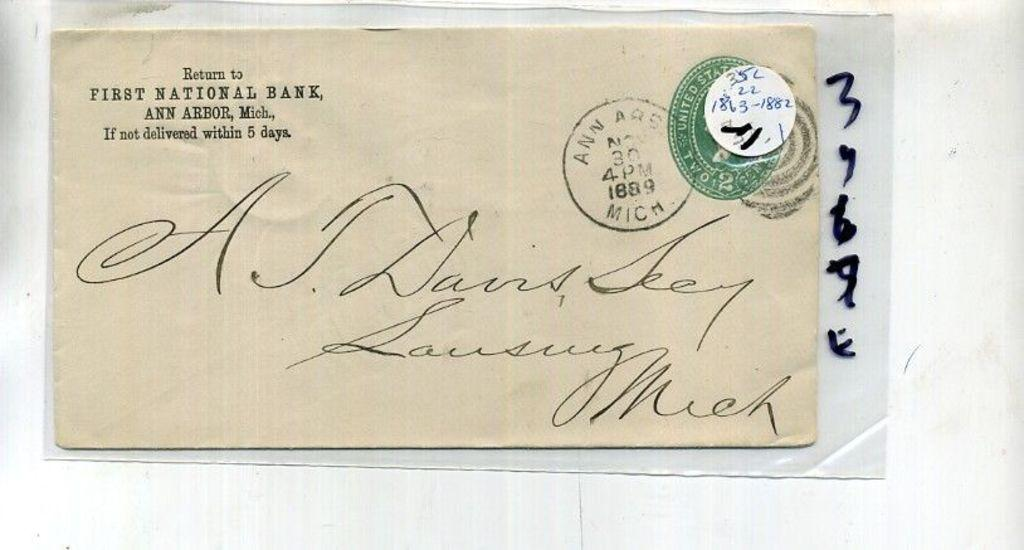<image>
Create a compact narrative representing the image presented. A letter from First National Bank in Mich. 